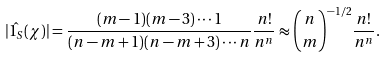Convert formula to latex. <formula><loc_0><loc_0><loc_500><loc_500>| \hat { 1 _ { S } } ( \chi ) | = \frac { ( m - 1 ) ( m - 3 ) \cdots 1 } { ( n - m + 1 ) ( n - m + 3 ) \cdots n } \frac { n ! } { n ^ { n } } \approx \binom { n } { m } ^ { - 1 / 2 } \frac { n ! } { n ^ { n } } .</formula> 